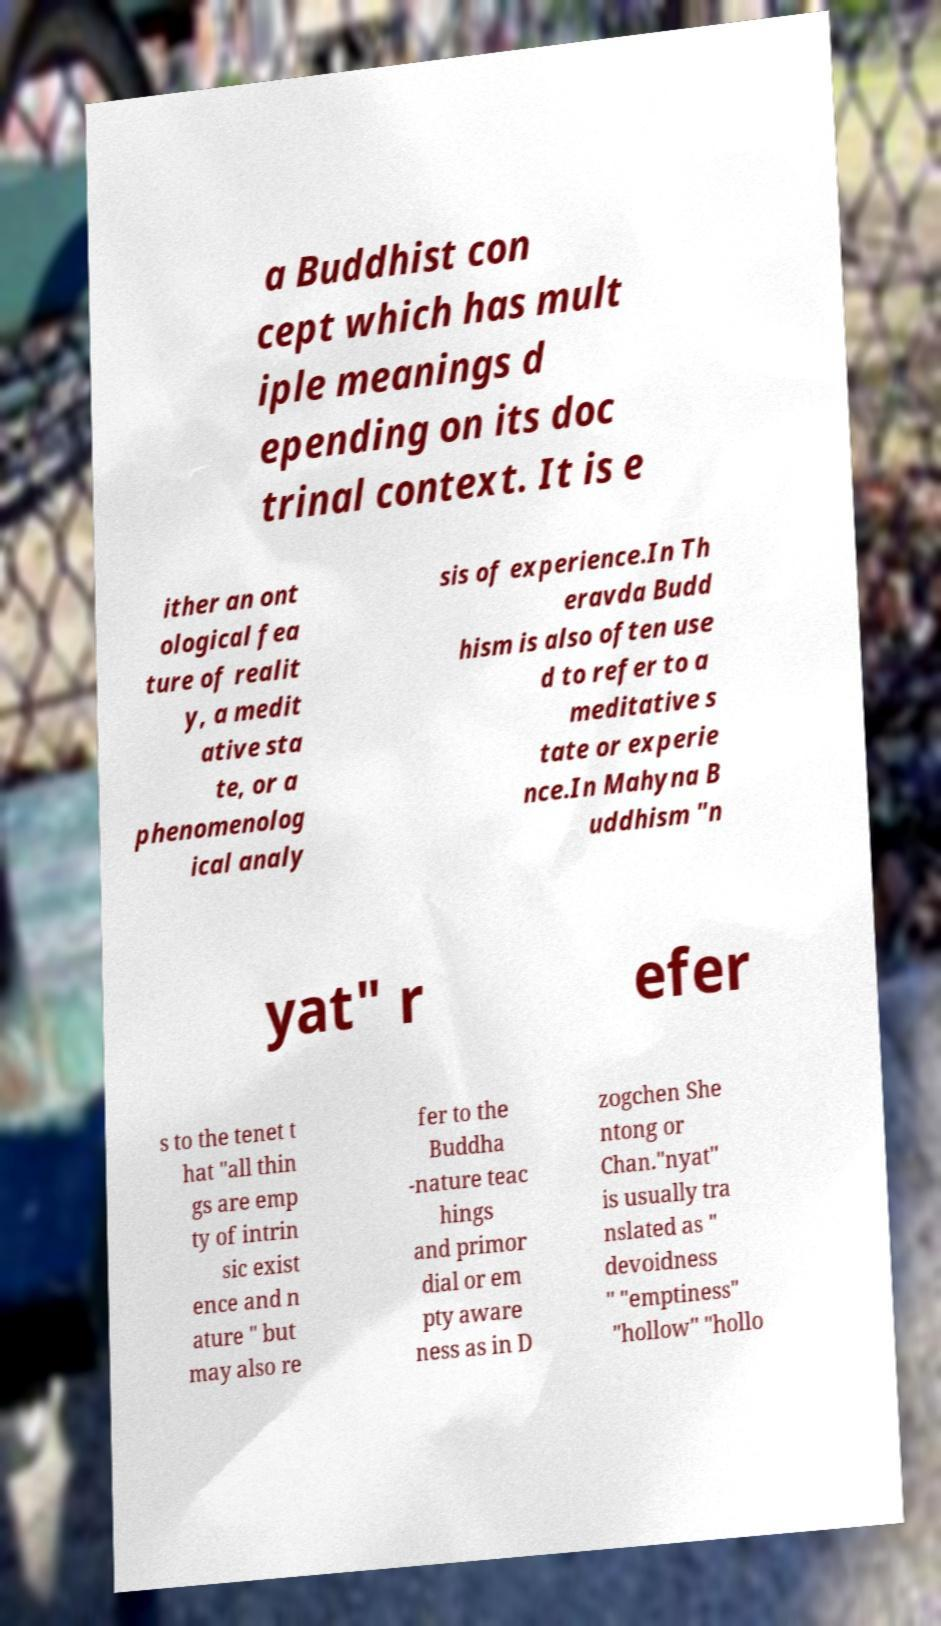Can you accurately transcribe the text from the provided image for me? a Buddhist con cept which has mult iple meanings d epending on its doc trinal context. It is e ither an ont ological fea ture of realit y, a medit ative sta te, or a phenomenolog ical analy sis of experience.In Th eravda Budd hism is also often use d to refer to a meditative s tate or experie nce.In Mahyna B uddhism "n yat" r efer s to the tenet t hat "all thin gs are emp ty of intrin sic exist ence and n ature " but may also re fer to the Buddha -nature teac hings and primor dial or em pty aware ness as in D zogchen She ntong or Chan."nyat" is usually tra nslated as " devoidness " "emptiness" "hollow" "hollo 